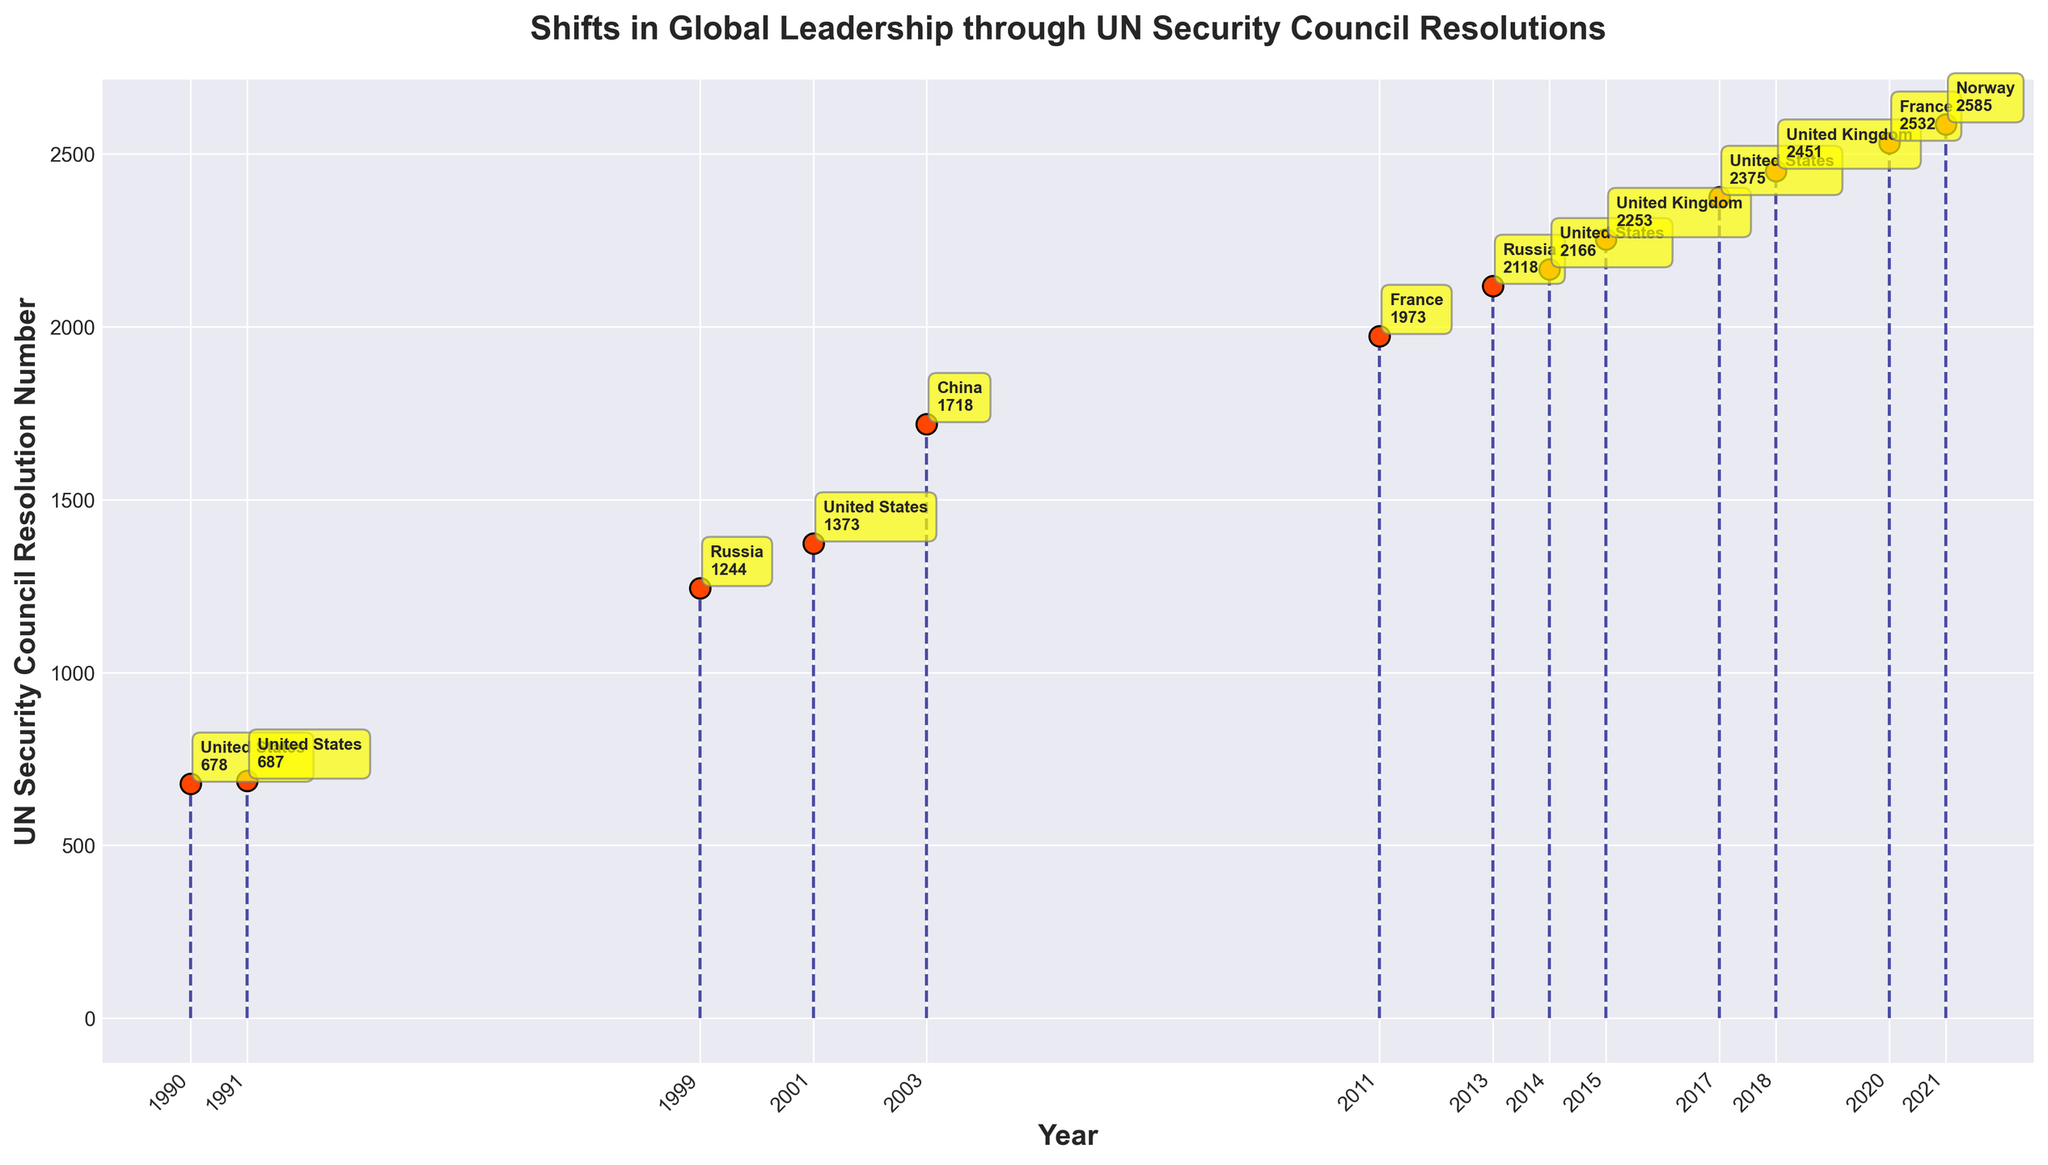What is the title of the plot? The title of the plot appears at the top and is usually the most prominent text. In this plot, it is clearly printed at the top.
Answer: Shifts in Global Leadership through UN Security Council Resolutions How many UN Security Council Resolutions are represented in the plot? To find the number of resolutions, we count the number of data points or markers plotted on the stem plot. Each marker corresponds to a resolution.
Answer: 13 Which country had the most resolutions represented on this plot? To determine this, look at the annotations next to each data point and count how many times each country's name appears.
Answer: United States What is the earliest year represented in the plot? The earliest year can be found by looking at the smallest value on the x-axis.
Answer: 1990 What is the resolution number for the year 2003? Locate the year 2003 on the x-axis and follow the stem to the data point. The resolution number is shown next to the marker.
Answer: 1718 Which resolution had the highest number? To find the highest resolution number, compare all the resolution numbers and identify the largest one.
Answer: 2585 Which two countries had resolutions represented in the year 2020 and 2021? Check the years 2020 and 2021 on the x-axis and see which countries are annotated near those data points.
Answer: France and Norway How many resolutions were passed by the United States after 2000? Count the number of data points after the year 2000 and check which ones are associated with the United States.
Answer: 4 Which year had the most recent resolution passed by the United Kingdom? Identify the data points associated with the United Kingdom and determine which one has the latest year.
Answer: 2018 What is the average resolution number for the resolutions passed in the 2010s? Find all the resolution numbers for the 2010s (2011 - 2019), sum them, and then divide by the number of those resolutions.
Answer: (1973 + 2118 + 2166 + 2253 + 2375 + 2451) / 6 = 2222.67 